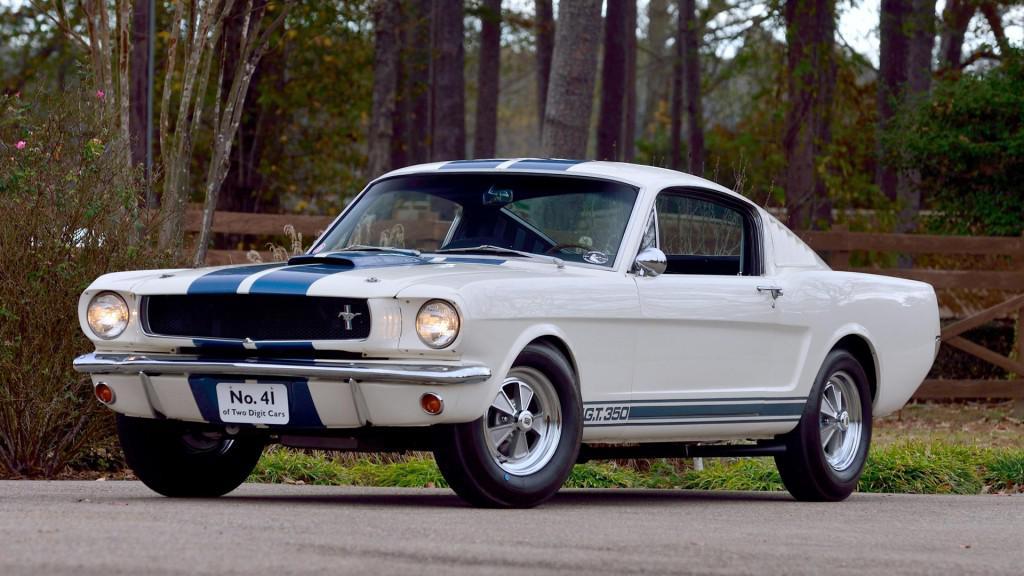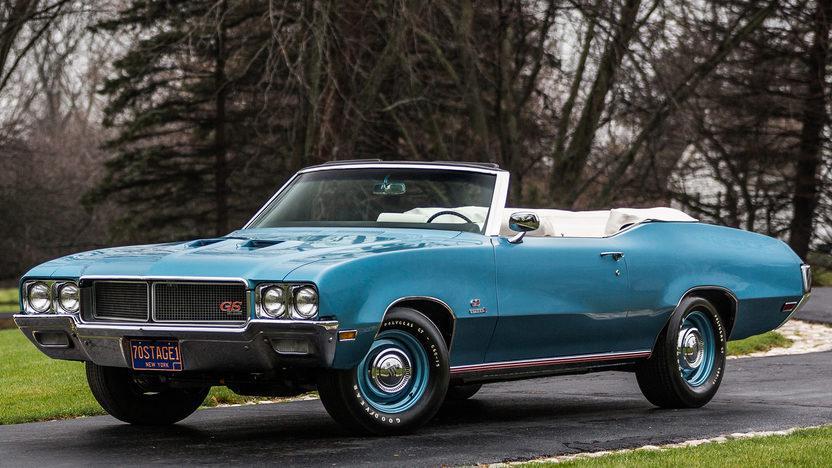The first image is the image on the left, the second image is the image on the right. Given the left and right images, does the statement "The image on the right contains a red convertible." hold true? Answer yes or no. No. 